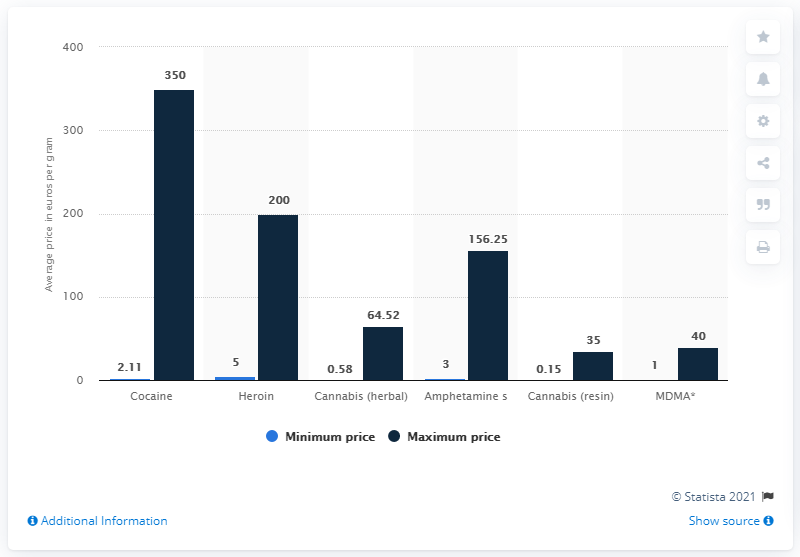What does the chart reveal about the price of MDMA compared to other drugs? The chart indicates that MDMA has a relatively lower average maximum price per gram compared to drugs like cocaine and heroin. It is priced closer to cannabis products, suggesting that MDMA may be more accessible or less strictly regulated, thus affecting its market price. 